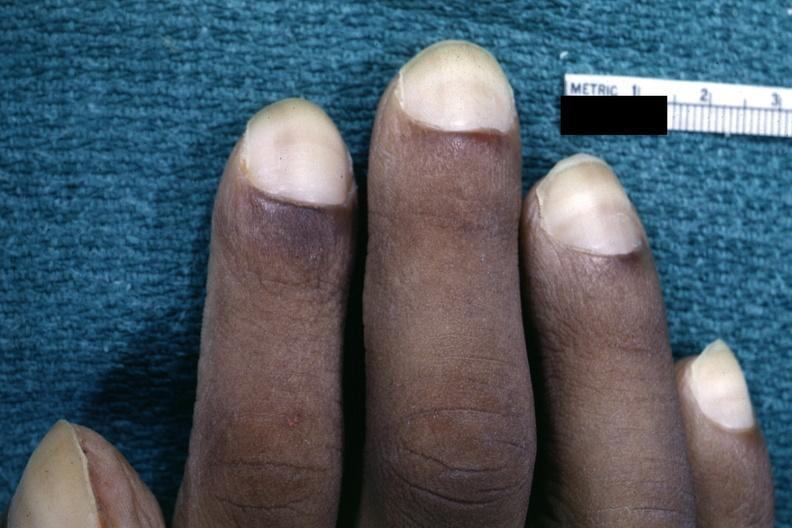what are present?
Answer the question using a single word or phrase. Extremities 